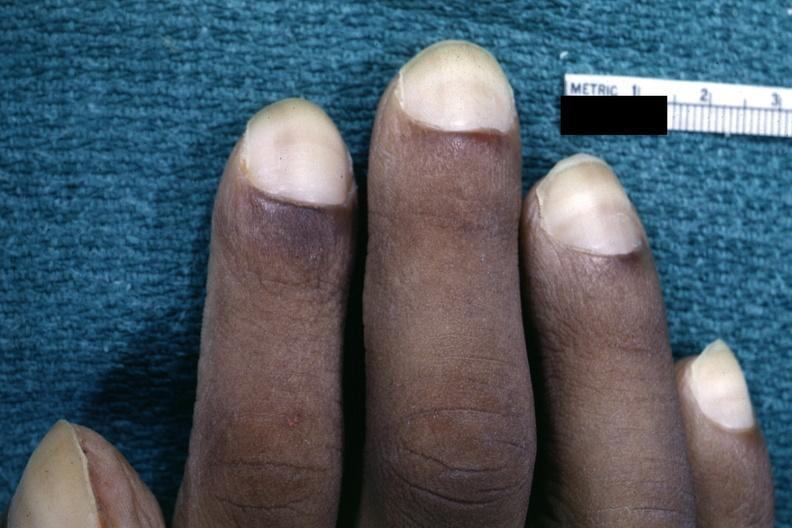what are present?
Answer the question using a single word or phrase. Extremities 